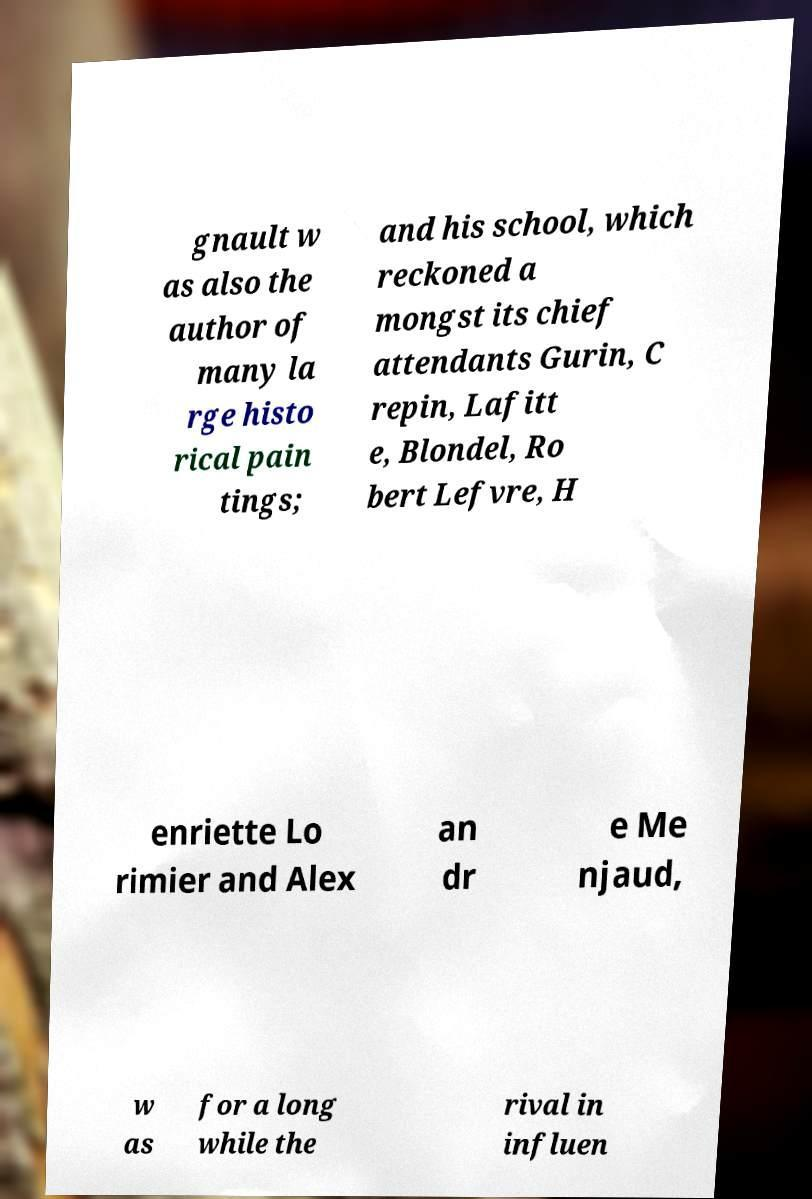Please read and relay the text visible in this image. What does it say? gnault w as also the author of many la rge histo rical pain tings; and his school, which reckoned a mongst its chief attendants Gurin, C repin, Lafitt e, Blondel, Ro bert Lefvre, H enriette Lo rimier and Alex an dr e Me njaud, w as for a long while the rival in influen 